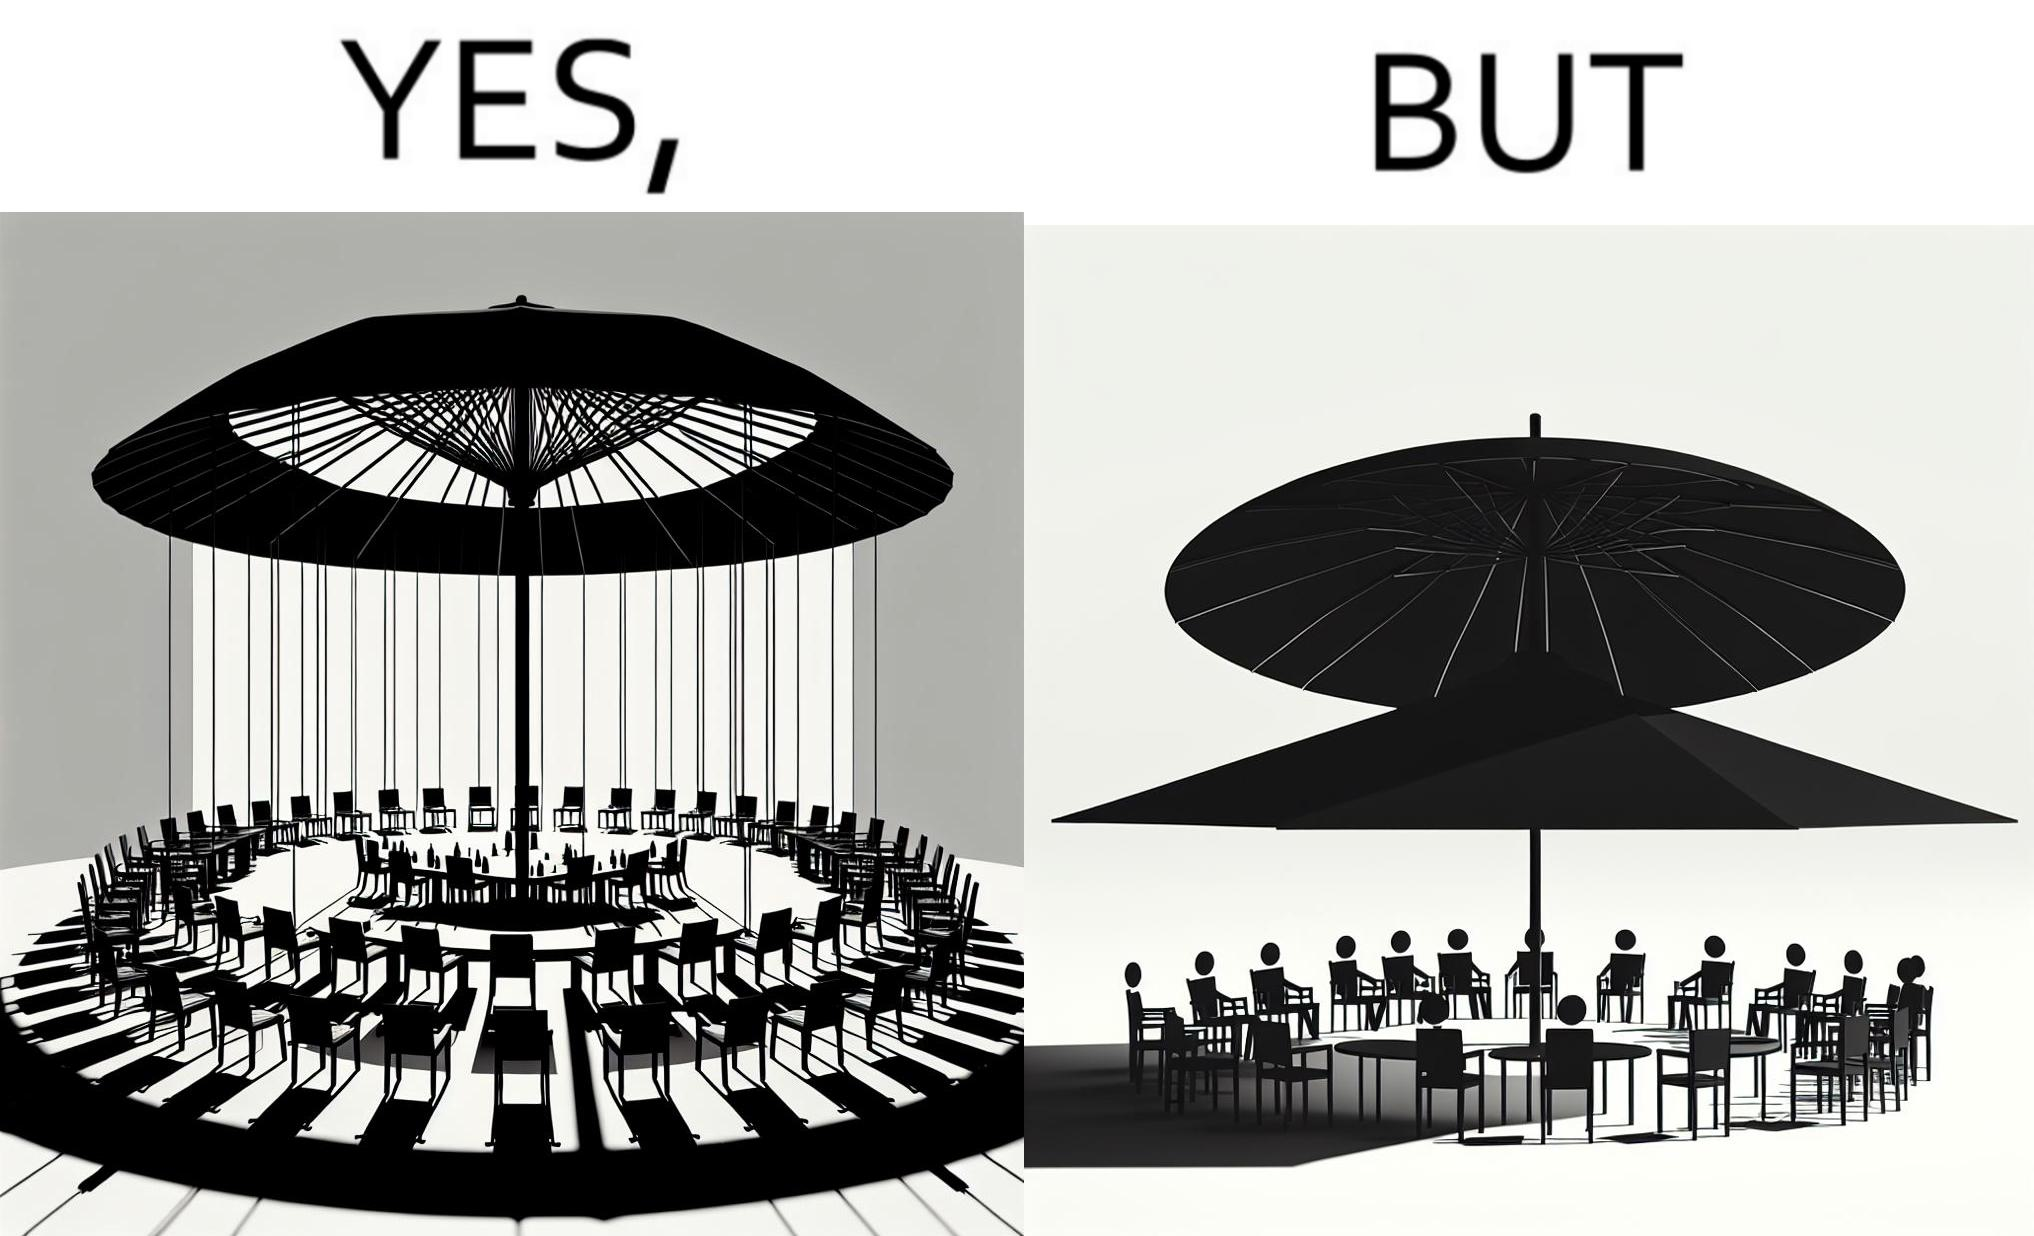Explain why this image is satirical. The image is ironical, as the umbrella is meant to provide shadow in the area where the chairs are present, but due to the orientation of the rays of the sun, all the chairs are in sunlight, and the umbrella is of no use in this situation. 